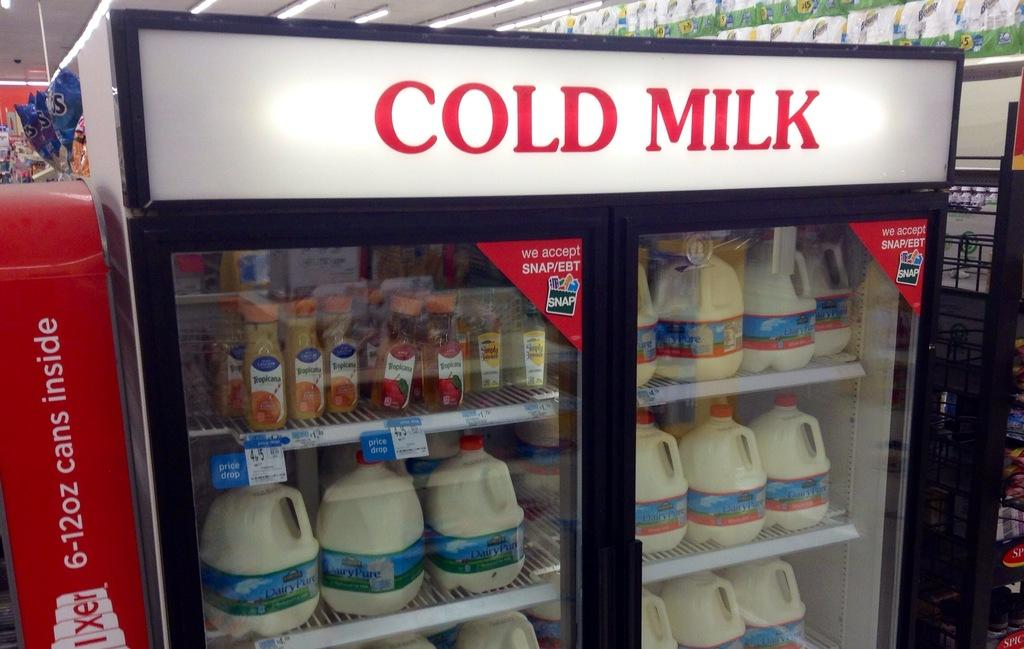Provide a one-sentence caption for the provided image. a refrigerator in a store that is labeled 'cold milk' in red. 